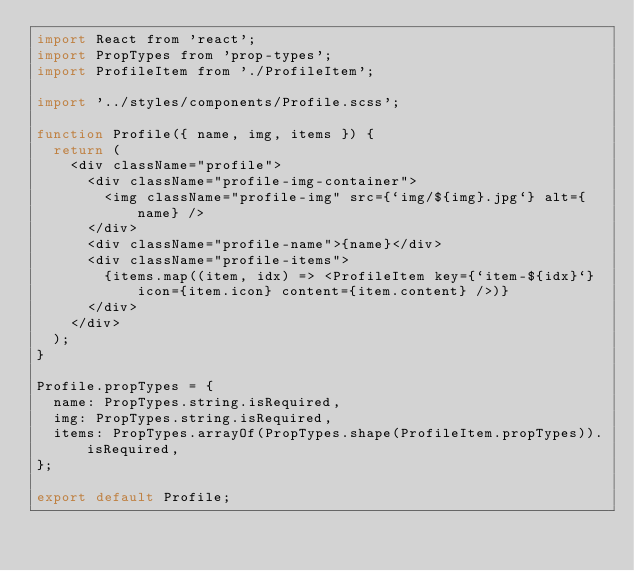Convert code to text. <code><loc_0><loc_0><loc_500><loc_500><_JavaScript_>import React from 'react';
import PropTypes from 'prop-types';
import ProfileItem from './ProfileItem';

import '../styles/components/Profile.scss';

function Profile({ name, img, items }) {
  return (
    <div className="profile">
      <div className="profile-img-container">
        <img className="profile-img" src={`img/${img}.jpg`} alt={name} />
      </div>
      <div className="profile-name">{name}</div>
      <div className="profile-items">
        {items.map((item, idx) => <ProfileItem key={`item-${idx}`} icon={item.icon} content={item.content} />)}
      </div>
    </div>
  );
}

Profile.propTypes = {
  name: PropTypes.string.isRequired,
  img: PropTypes.string.isRequired,
  items: PropTypes.arrayOf(PropTypes.shape(ProfileItem.propTypes)).isRequired,
};

export default Profile;
</code> 